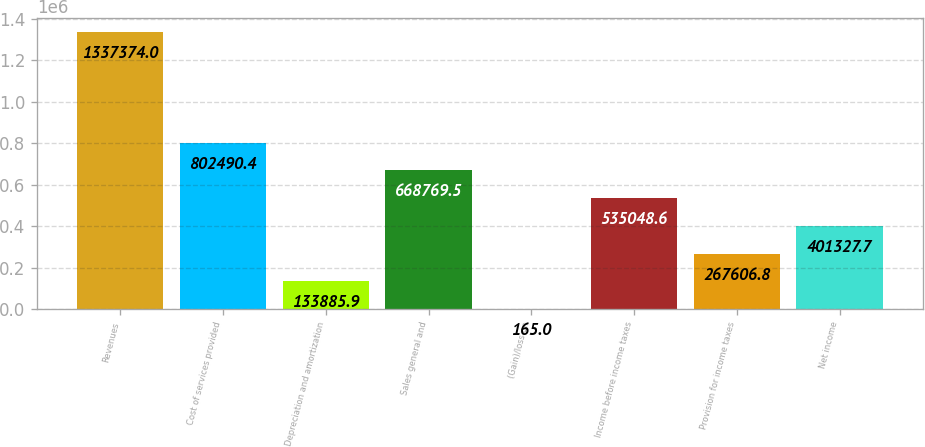<chart> <loc_0><loc_0><loc_500><loc_500><bar_chart><fcel>Revenues<fcel>Cost of services provided<fcel>Depreciation and amortization<fcel>Sales general and<fcel>(Gain)/loss on<fcel>Income before income taxes<fcel>Provision for income taxes<fcel>Net income<nl><fcel>1.33737e+06<fcel>802490<fcel>133886<fcel>668770<fcel>165<fcel>535049<fcel>267607<fcel>401328<nl></chart> 